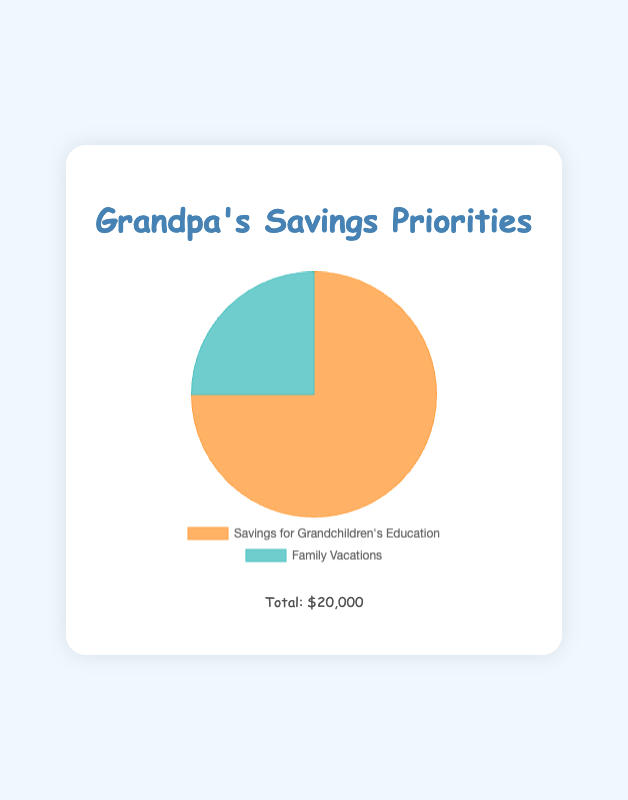What is the total amount saved for both education and vacations? To find the total amount saved, sum the values for Savings for Grandchildren's Education ($15,000) and Family Vacations ($5,000). Therefore, $15,000 + $5,000 = $20,000.
Answer: $20,000 Which category has more savings? Compare the amounts: Savings for Grandchildren's Education has $15,000, and Family Vacations has $5,000. Since $15,000 is greater than $5,000, the Savings for Grandchildren's Education category has more savings.
Answer: Savings for Grandchildren's Education How much more is saved for education compared to vacations? Subtract the amount saved for Family Vacations ($5,000) from the amount saved for Savings for Grandchildren's Education ($15,000). So, $15,000 - $5,000 = $10,000.
Answer: $10,000 What fraction of the total savings is allocated to family vacations? Divide the amount saved for Family Vacations ($5,000) by the total savings ($20,000). So, $5,000 / $20,000 = 0.25. This is 25% when converted to a percentage.
Answer: 25% What are the colors used to represent the two categories? Visually identify the colors used in the pie chart. Savings for Grandchildren's Education is represented by an orange color, and Family Vacations is represented by a teal color.
Answer: Orange and Teal If the total savings were to increase by $10,000 equally distributed between both categories, what would the new amounts be for each? First, add $5,000 to each category. For Savings for Grandchildren's Education: $15,000 + $5,000 = $20,000. For Family Vacations: $5,000 + $5,000 = $10,000.
Answer: Education: $20,000, Vacations: $10,000 What percentage of the total savings is dedicated to grandchildren’s education? Divide the amount saved for education ($15,000) by the total savings ($20,000), then multiply by 100 to get the percentage. ($15,000 / $20,000) * 100 = 75%.
Answer: 75% If you wanted to split an additional $2,000 equally between both savings categories, how much would each category receive? Divide the additional amount ($2,000) equally between the two categories. So, $2,000 / 2 = $1,000 for each.
Answer: $1,000 each Between education and vacations, which category uses a cooler color tone? Visually compare the colors used; a teal color is cooler than an orange color. Therefore, the Family Vacations category uses a cooler color tone.
Answer: Family Vacations 